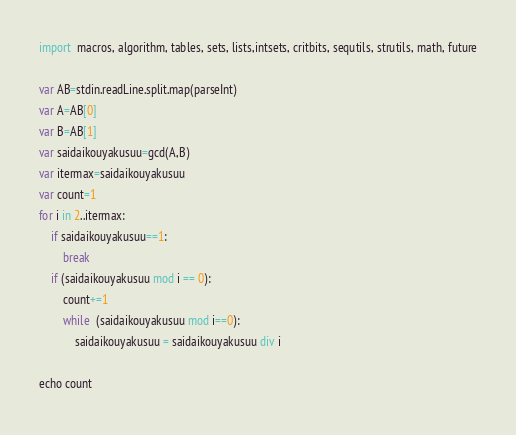<code> <loc_0><loc_0><loc_500><loc_500><_Nim_>import  macros, algorithm, tables, sets, lists,intsets, critbits, sequtils, strutils, math, future

var AB=stdin.readLine.split.map(parseInt)
var A=AB[0]
var B=AB[1]
var saidaikouyakusuu=gcd(A,B)
var itermax=saidaikouyakusuu
var count=1
for i in 2..itermax:
    if saidaikouyakusuu==1:
        break
    if (saidaikouyakusuu mod i == 0):
        count+=1
        while  (saidaikouyakusuu mod i==0):
            saidaikouyakusuu = saidaikouyakusuu div i

echo count

</code> 